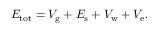Convert formula to latex. <formula><loc_0><loc_0><loc_500><loc_500>E _ { t o t } = V _ { g } + E _ { s } + V _ { w } + V _ { e } .</formula> 